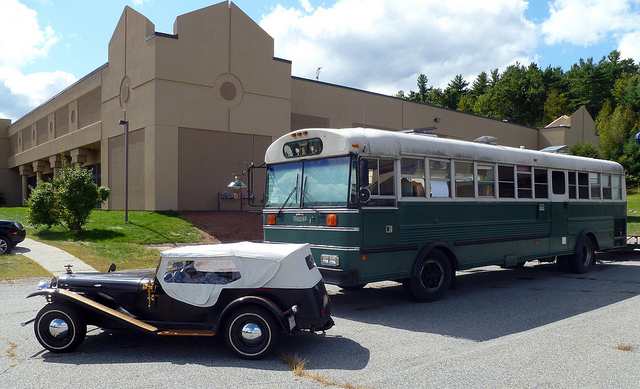<image>What is the building in the background? I am not sure about the building in the background. It can be an office, bus depot, school, library, church or mall. What is the building in the background? I am not sure what the building in the background is. It can be seen as an office, bus depot, school, library, church, mall or unknown. 